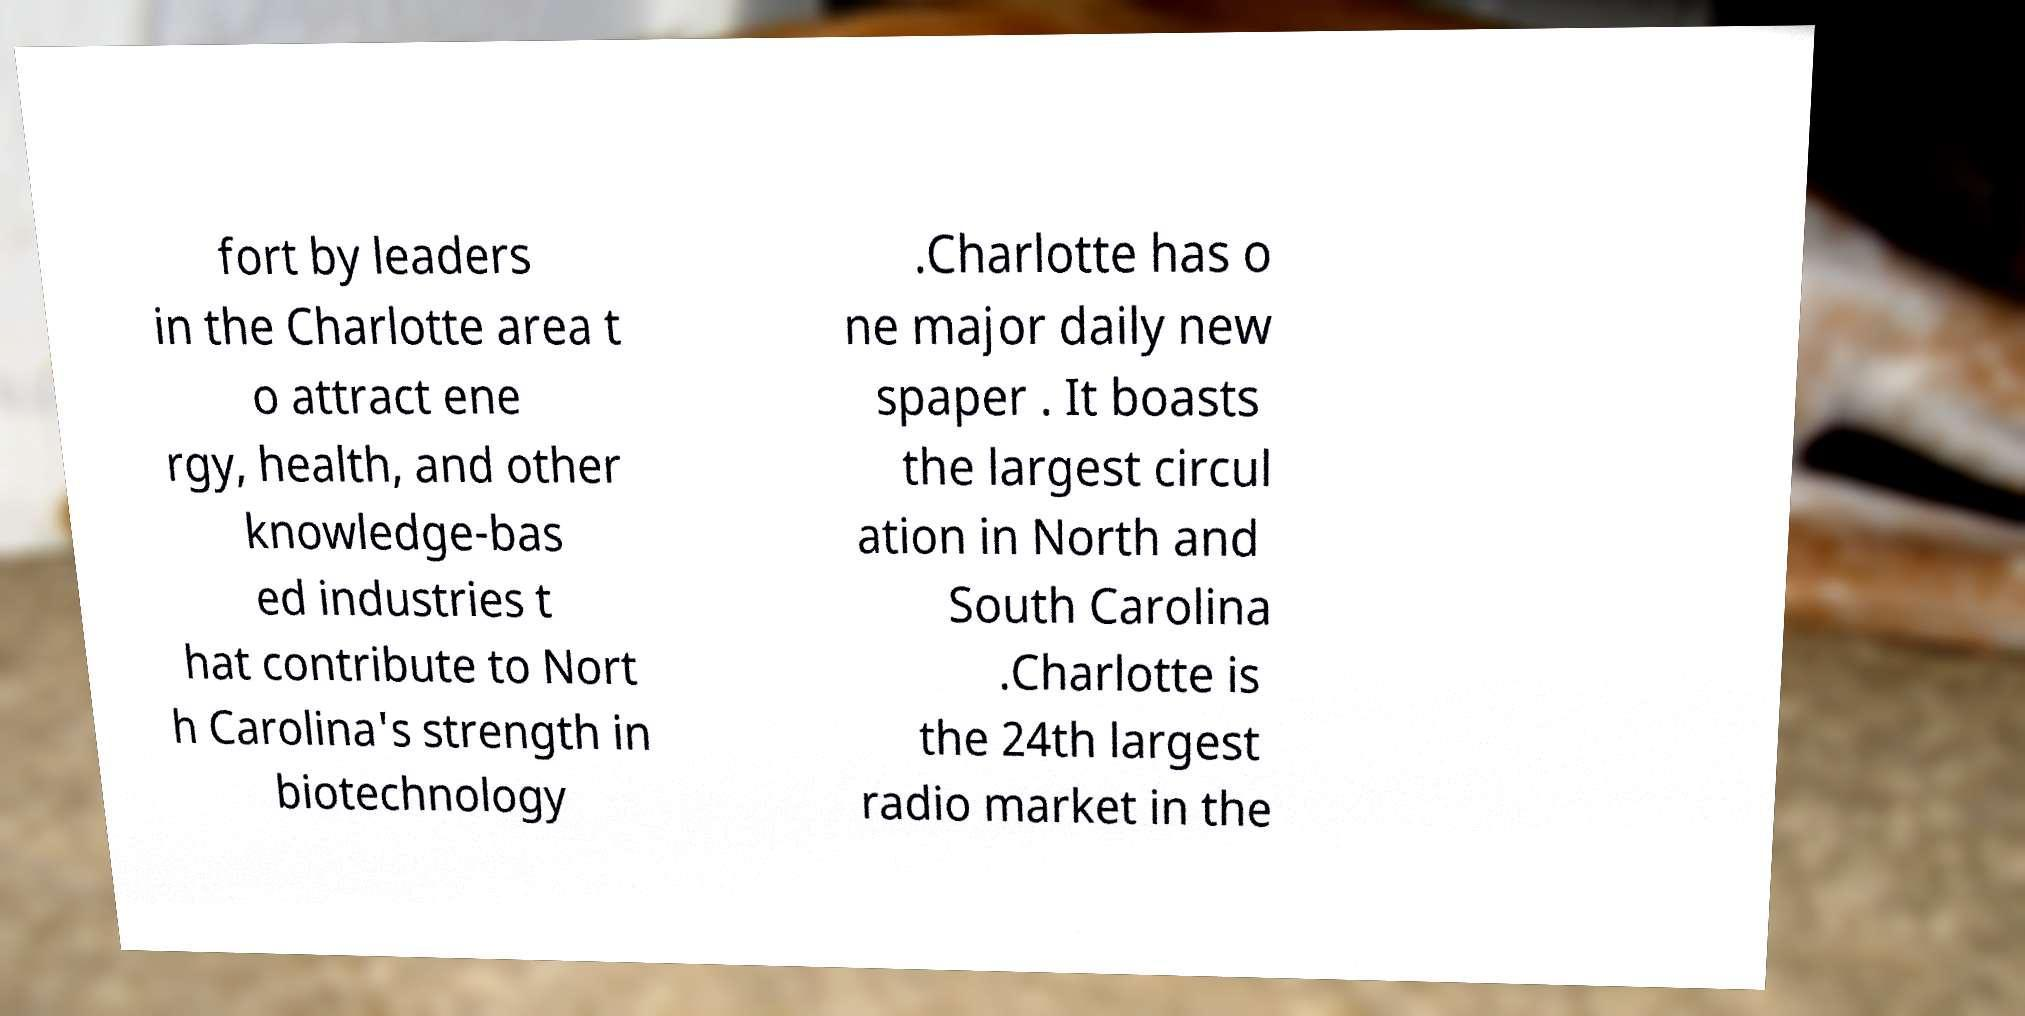Please read and relay the text visible in this image. What does it say? fort by leaders in the Charlotte area t o attract ene rgy, health, and other knowledge-bas ed industries t hat contribute to Nort h Carolina's strength in biotechnology .Charlotte has o ne major daily new spaper . It boasts the largest circul ation in North and South Carolina .Charlotte is the 24th largest radio market in the 